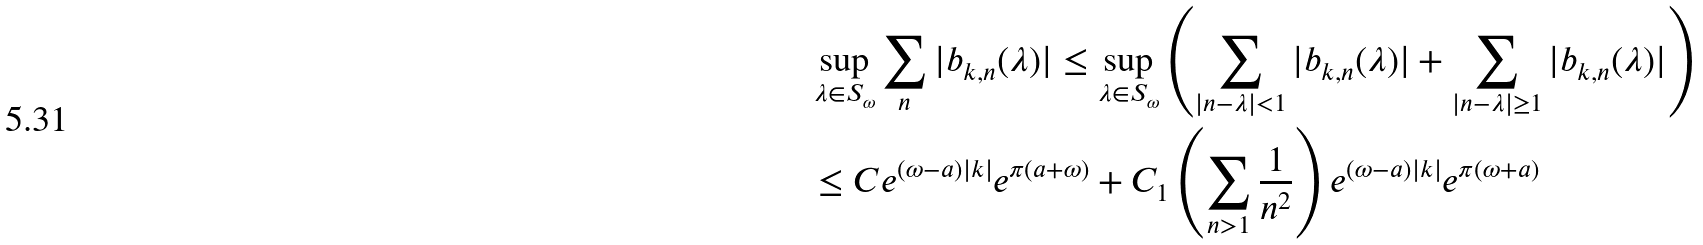Convert formula to latex. <formula><loc_0><loc_0><loc_500><loc_500>& \sup _ { \lambda \in S _ { \omega } } \sum _ { n } | b _ { k , n } ( \lambda ) | \leq \sup _ { \lambda \in S _ { \omega } } \left ( \sum _ { | n - \lambda | < 1 } | b _ { k , n } ( \lambda ) | + \sum _ { | n - \lambda | \geq 1 } | b _ { k , n } ( \lambda ) | \right ) \\ & \leq C e ^ { ( \omega - a ) | k | } e ^ { \pi ( a + \omega ) } + C _ { 1 } \left ( \sum _ { n > 1 } \frac { 1 } { n ^ { 2 } } \right ) e ^ { ( \omega - a ) | k | } e ^ { \pi ( \omega + a ) }</formula> 